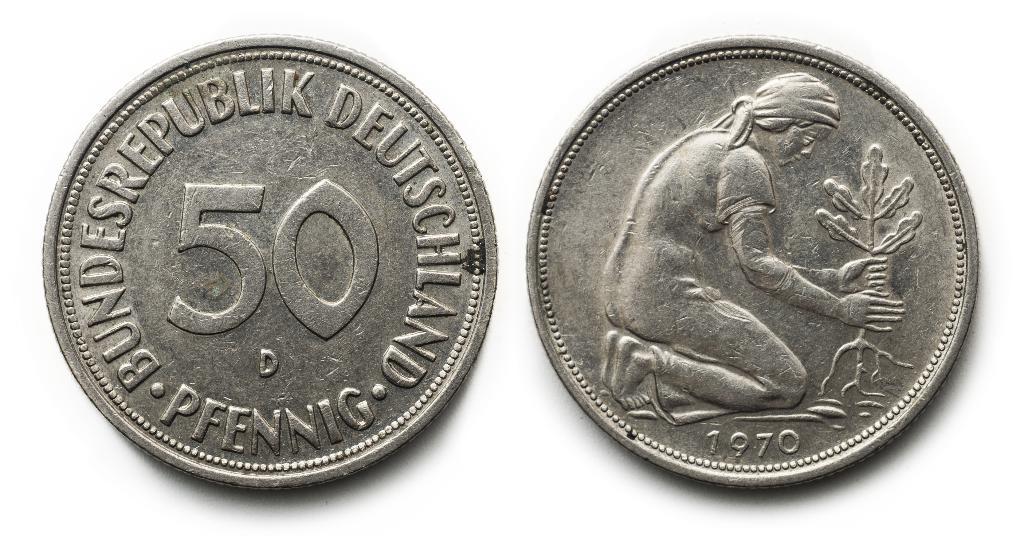What year is this coin?
Keep it short and to the point. 1970. What number ison the coin?
Give a very brief answer. 50. 